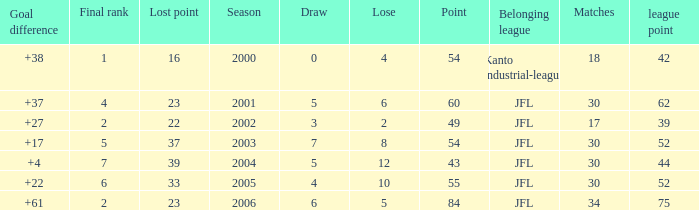I want the total number of matches for draw less than 7 and lost point of 16 with lose more than 4 0.0. 